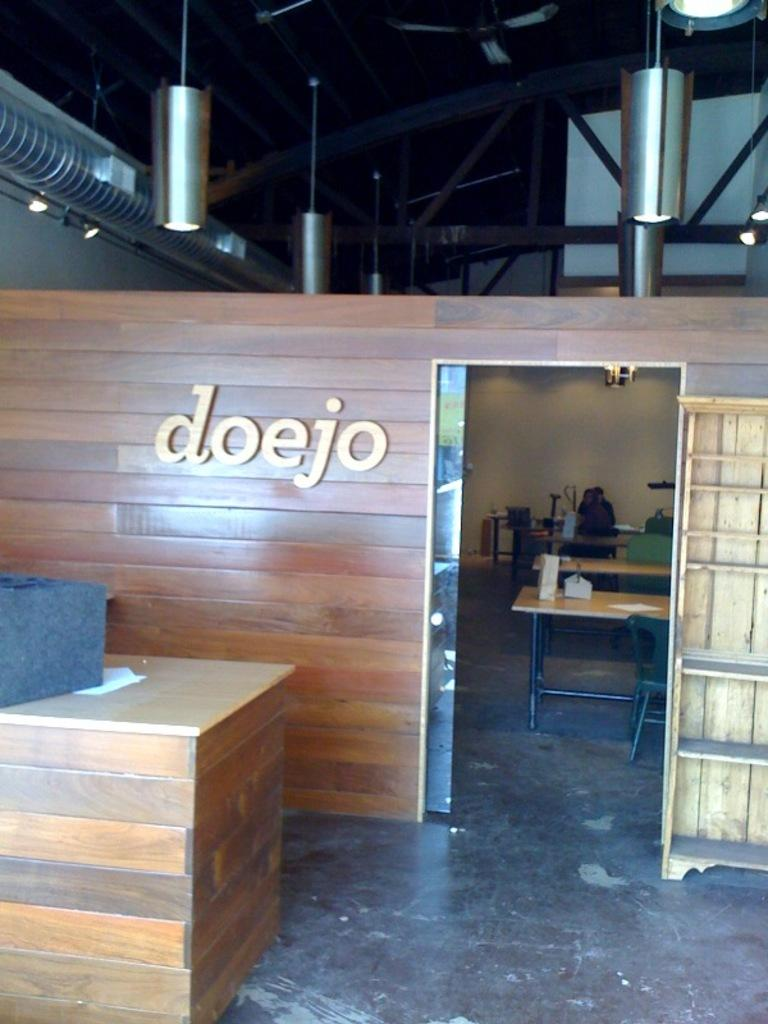<image>
Provide a brief description of the given image. The name of the room is called the doejo 